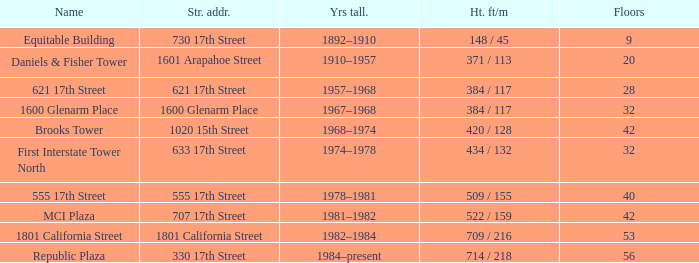What is the height of the building named 555 17th street? 509 / 155. 